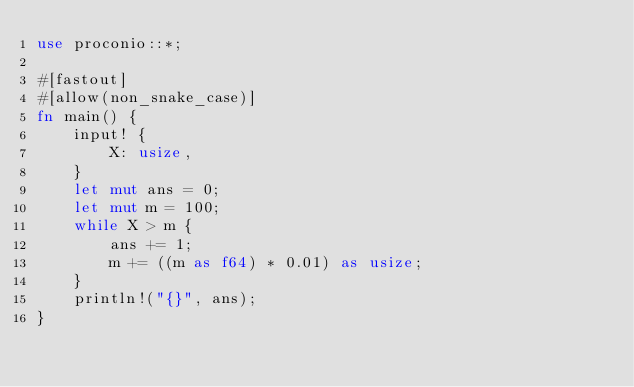Convert code to text. <code><loc_0><loc_0><loc_500><loc_500><_Rust_>use proconio::*;

#[fastout]
#[allow(non_snake_case)]
fn main() {
    input! {
        X: usize,
    }
    let mut ans = 0;
    let mut m = 100;
    while X > m {
        ans += 1;
        m += ((m as f64) * 0.01) as usize;
    }
    println!("{}", ans);
}
</code> 